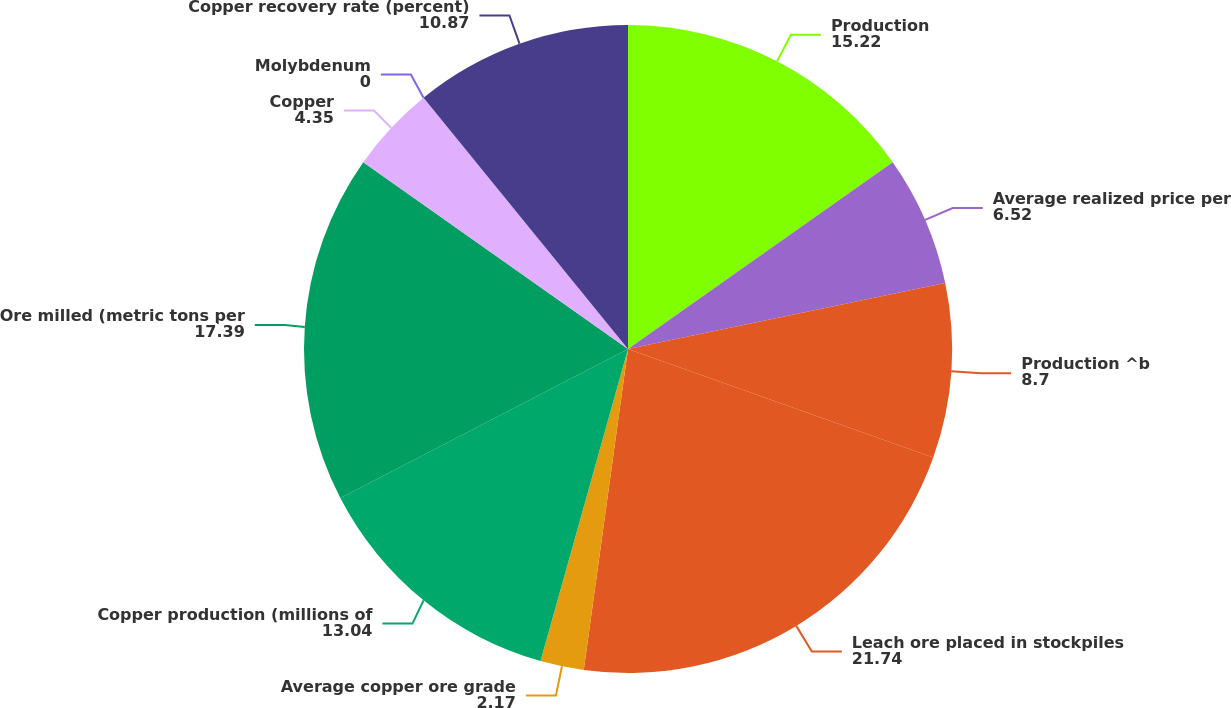<chart> <loc_0><loc_0><loc_500><loc_500><pie_chart><fcel>Production<fcel>Average realized price per<fcel>Production ^b<fcel>Leach ore placed in stockpiles<fcel>Average copper ore grade<fcel>Copper production (millions of<fcel>Ore milled (metric tons per<fcel>Copper<fcel>Molybdenum<fcel>Copper recovery rate (percent)<nl><fcel>15.22%<fcel>6.52%<fcel>8.7%<fcel>21.74%<fcel>2.17%<fcel>13.04%<fcel>17.39%<fcel>4.35%<fcel>0.0%<fcel>10.87%<nl></chart> 